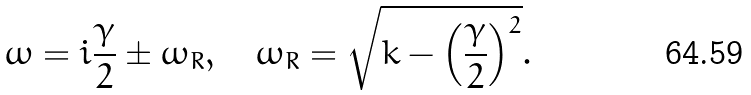<formula> <loc_0><loc_0><loc_500><loc_500>\omega = i \frac { \gamma } { 2 } \pm \omega _ { R } , \quad \omega _ { R } = \sqrt { k - \left ( \frac { \gamma } { 2 } \right ) ^ { 2 } } .</formula> 